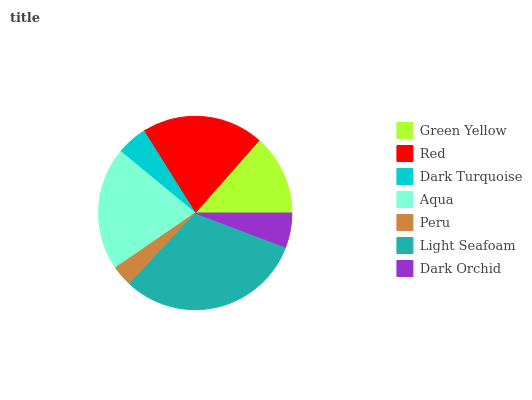Is Peru the minimum?
Answer yes or no. Yes. Is Light Seafoam the maximum?
Answer yes or no. Yes. Is Red the minimum?
Answer yes or no. No. Is Red the maximum?
Answer yes or no. No. Is Red greater than Green Yellow?
Answer yes or no. Yes. Is Green Yellow less than Red?
Answer yes or no. Yes. Is Green Yellow greater than Red?
Answer yes or no. No. Is Red less than Green Yellow?
Answer yes or no. No. Is Green Yellow the high median?
Answer yes or no. Yes. Is Green Yellow the low median?
Answer yes or no. Yes. Is Dark Orchid the high median?
Answer yes or no. No. Is Dark Orchid the low median?
Answer yes or no. No. 